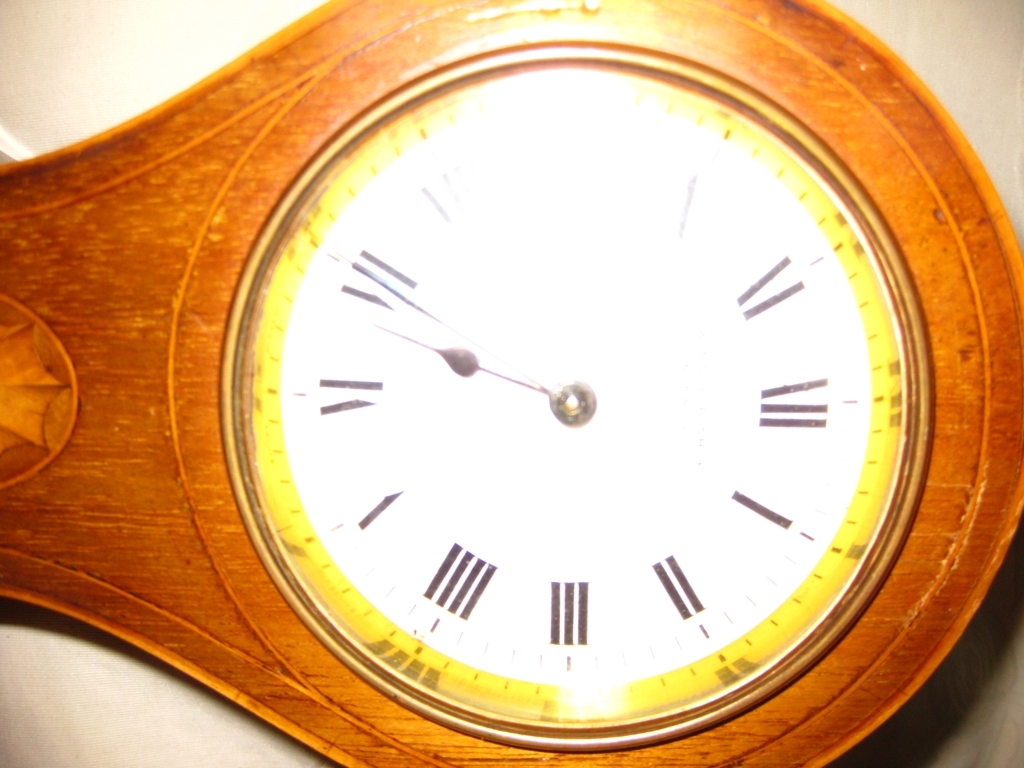How does the lighting affect the perception of this clock? The lighting in this image causes the clock to appear slightly overexposed in the center, which not only washes out some of the details of the face but also gives a dramatic, radiant effect to the timepiece. It could signify the clock being highlighted as a focal point in a room or a spotlight effect during a specific time of day when sunlight hits it directly. 